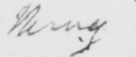What text is written in this handwritten line? thing 